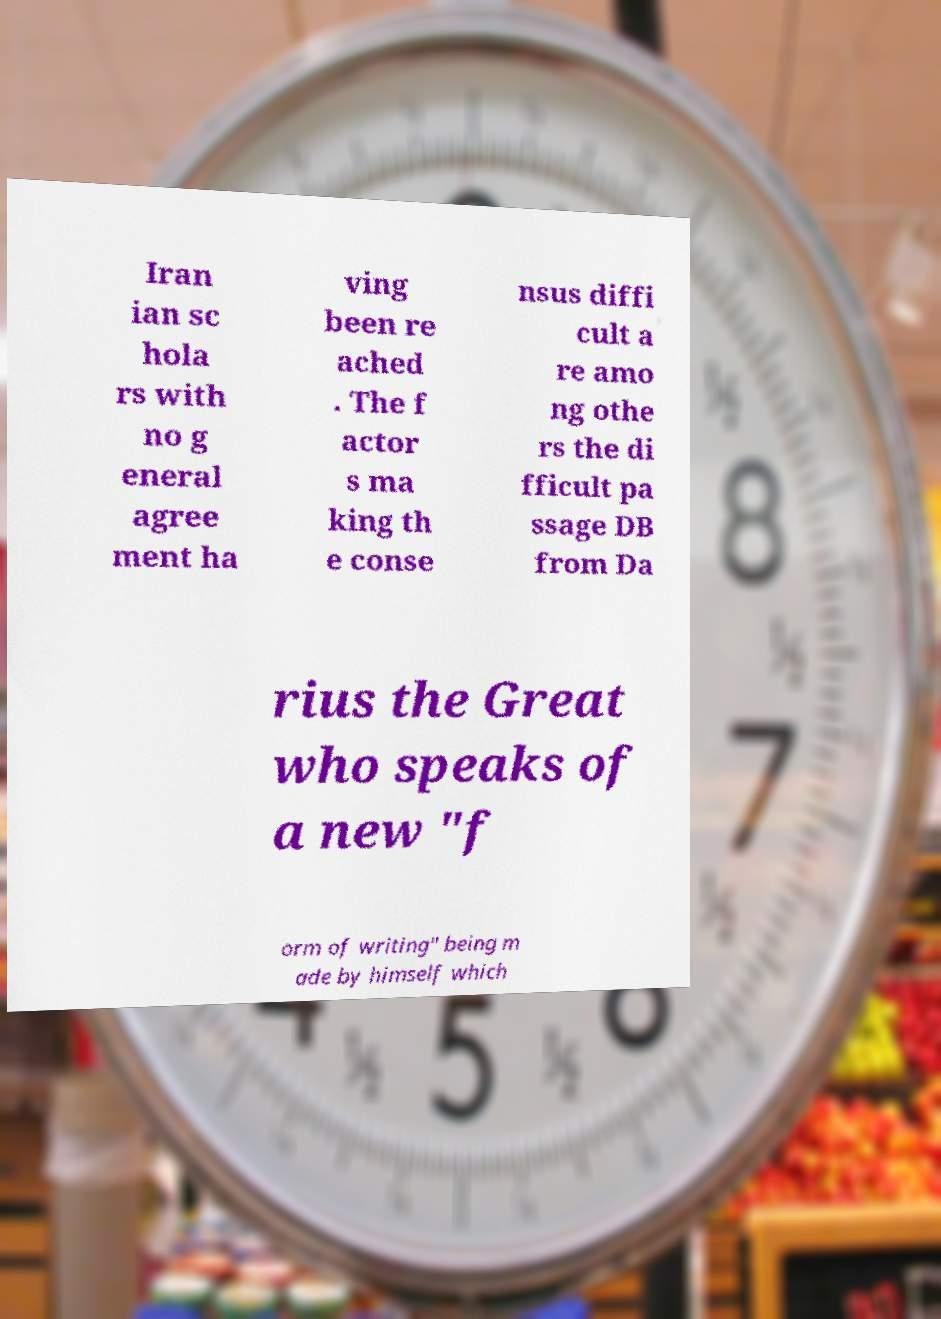What messages or text are displayed in this image? I need them in a readable, typed format. Iran ian sc hola rs with no g eneral agree ment ha ving been re ached . The f actor s ma king th e conse nsus diffi cult a re amo ng othe rs the di fficult pa ssage DB from Da rius the Great who speaks of a new "f orm of writing" being m ade by himself which 